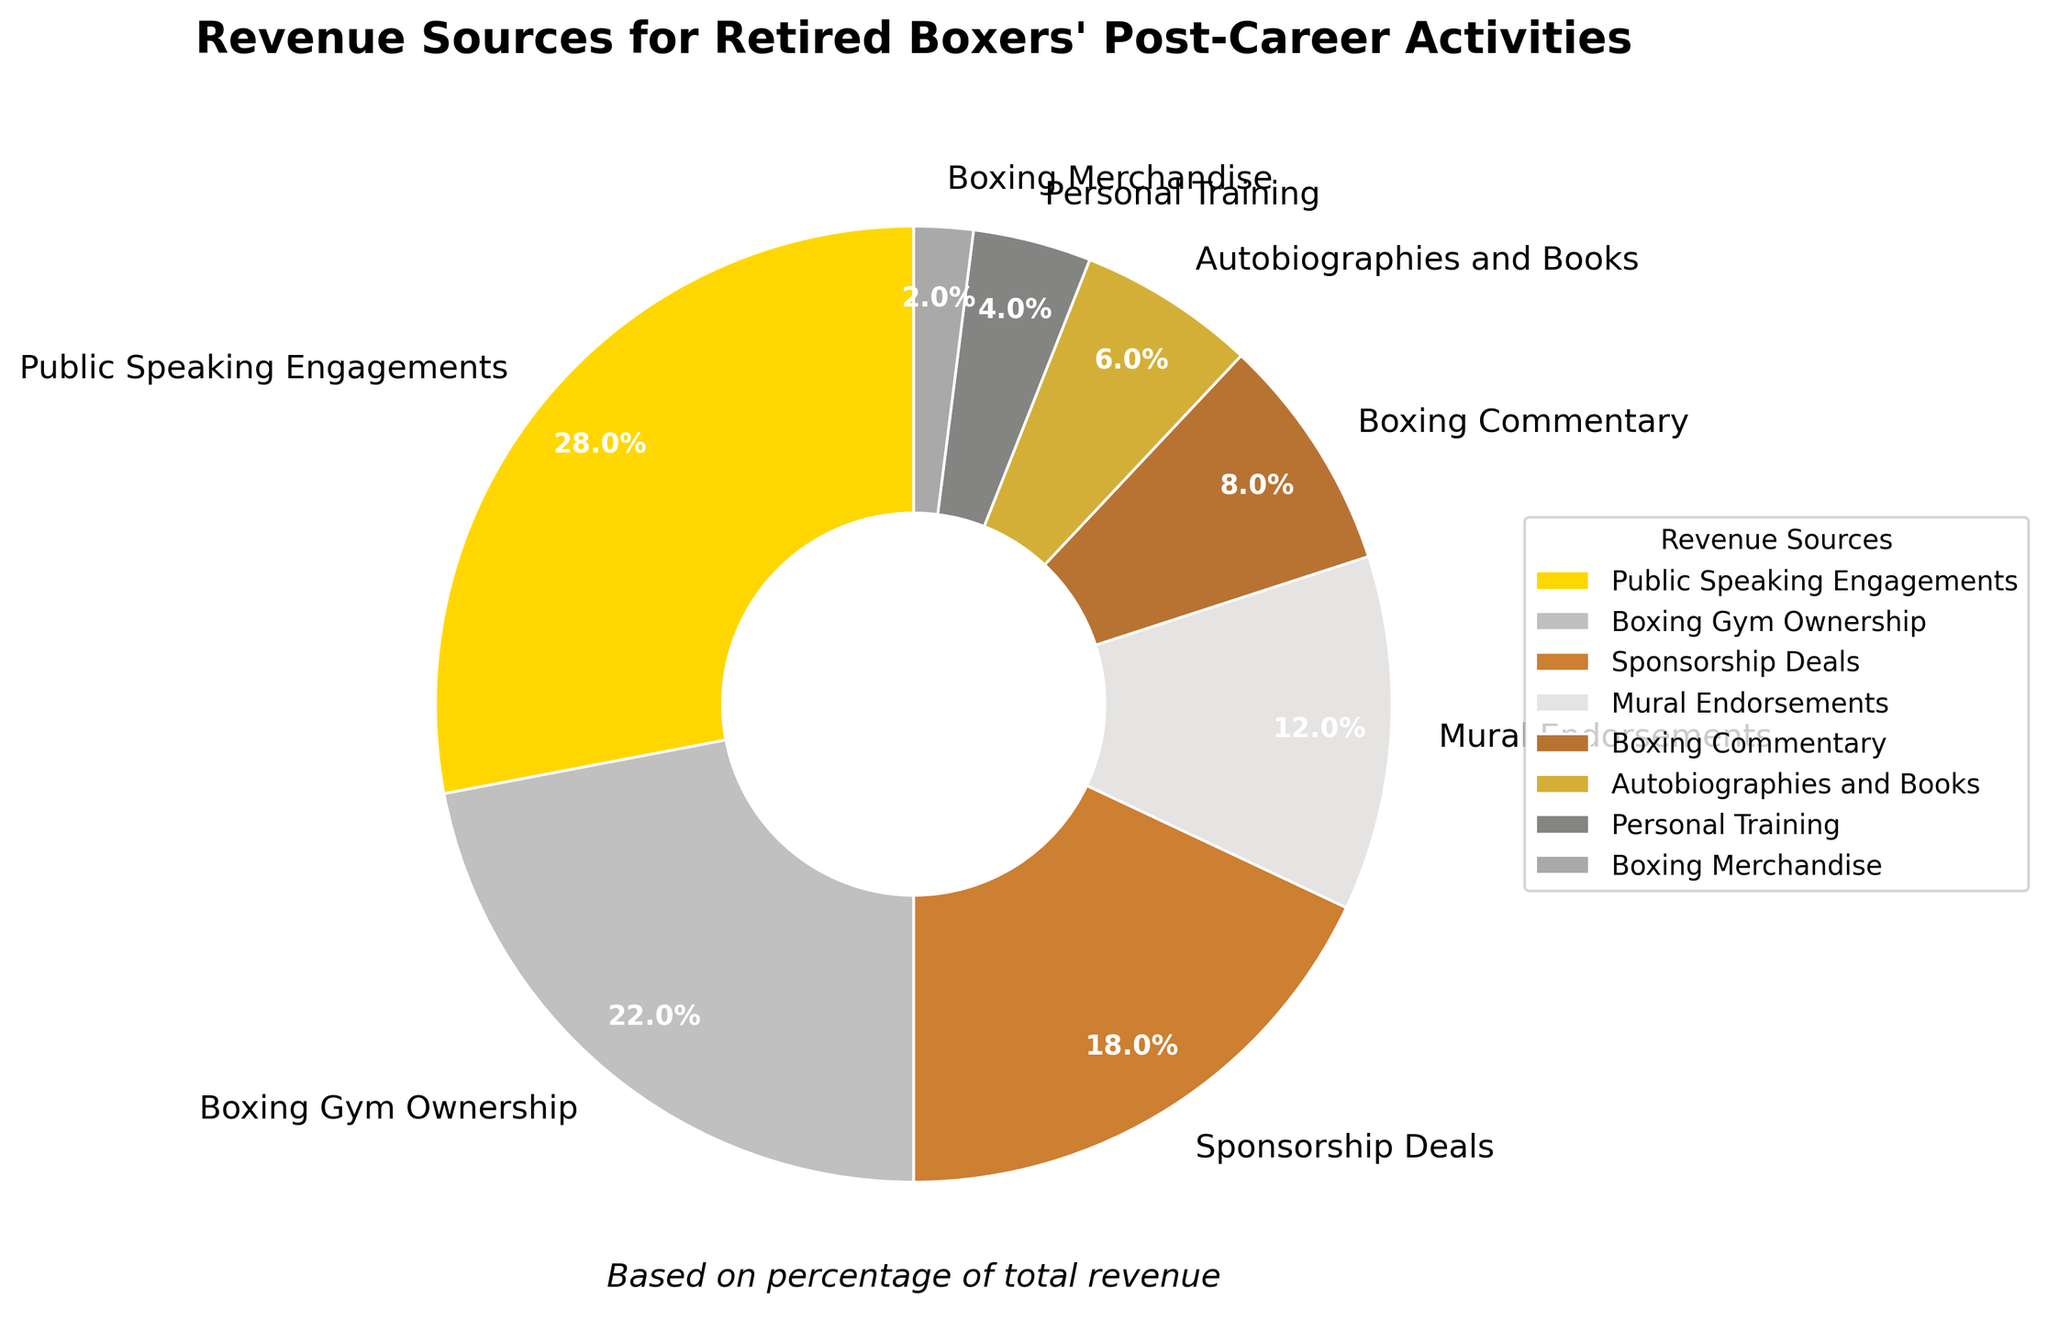Which revenue source contributes the most to post-career activities of retired boxers? The largest percentage slice in the pie chart represents Public Speaking Engagements, which contributes 28% of the total revenue.
Answer: Public Speaking Engagements What is the combined percentage of revenue from Sponsorship Deals and Mural Endorsements? The percentage from Sponsorship Deals is 18% and from Mural Endorsements is 12%. Summing these two gives 18% + 12% = 30%.
Answer: 30% Is the revenue from Boxing Gym Ownership greater than the revenue from Boxing Commentary? The percentage from Boxing Gym Ownership is 22%, and from Boxing Commentary is 8%. Since 22% is greater than 8%, the revenue from Boxing Gym Ownership is greater.
Answer: Yes Which slice of the pie chart is visually the smallest, and what is its percentage? The smallest slice visually is the one representing Boxing Merchandise, which has a percentage of 2%.
Answer: Boxing Merchandise, 2% How much more does Public Speaking Engagements contribute to the revenue compared to Autobiographies and Books? The percentage from Public Speaking Engagements is 28%, and from Autobiographies and Books is 6%. The difference is 28% - 6% = 22%.
Answer: 22% What is the sum of the percentages of revenue from Autobiographies and Books, Personal Training, and Boxing Merchandise? The percentages are 6% (Autobiographies and Books), 4% (Personal Training), and 2% (Boxing Merchandise). Their sum is 6% + 4% + 2% = 12%.
Answer: 12% Which revenue source is represented by the silver color in the pie chart? The second largest segment in the pie chart, colored silver, corresponds to Boxing Gym Ownership with 22%.
Answer: Boxing Gym Ownership Between Boxing Commentary and Personal Training, which source contributes less to the revenue? The percentage from Boxing Commentary is 8%, and from Personal Training is 4%. Therefore, Personal Training contributes less.
Answer: Personal Training What percentage of total revenue comes from the top two revenue sources combined? The top two revenue sources are Public Speaking Engagements (28%) and Boxing Gym Ownership (22%). Their combined percentage is 28% + 22% = 50%.
Answer: 50% Is the percentage of revenue from Boxing Merchandise less than half of the revenue from Personal Training? The percentage from Boxing Merchandise is 2%, and from Personal Training is 4%. Since 2% is exactly half of 4%, the revenue from Boxing Merchandise is not less than half.
Answer: No 